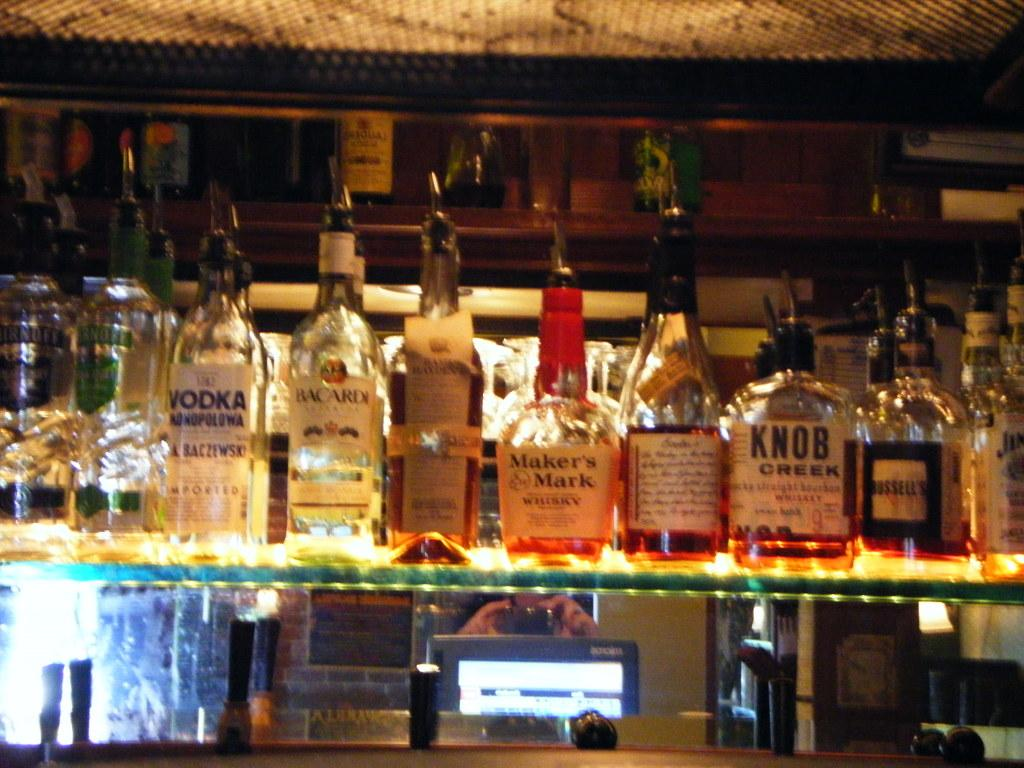<image>
Write a terse but informative summary of the picture. Bottles of whiskey one by Makers Mark sit on display in a bar 